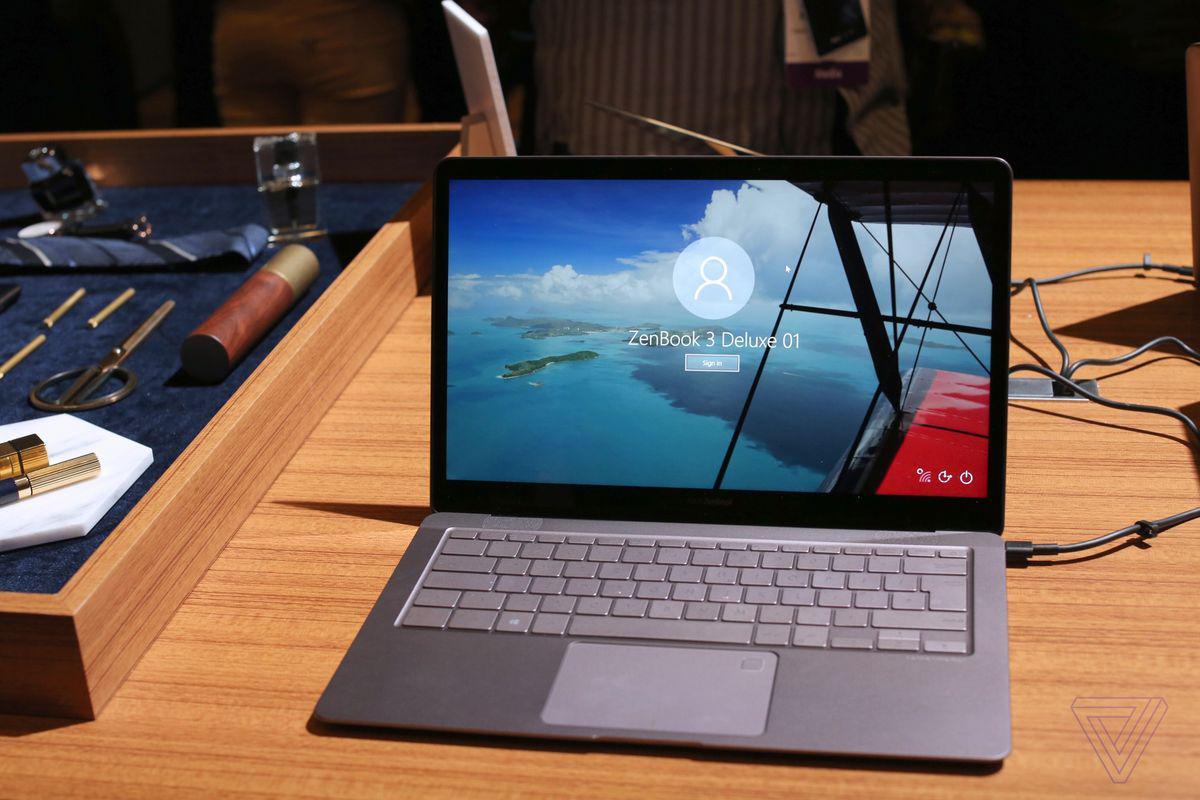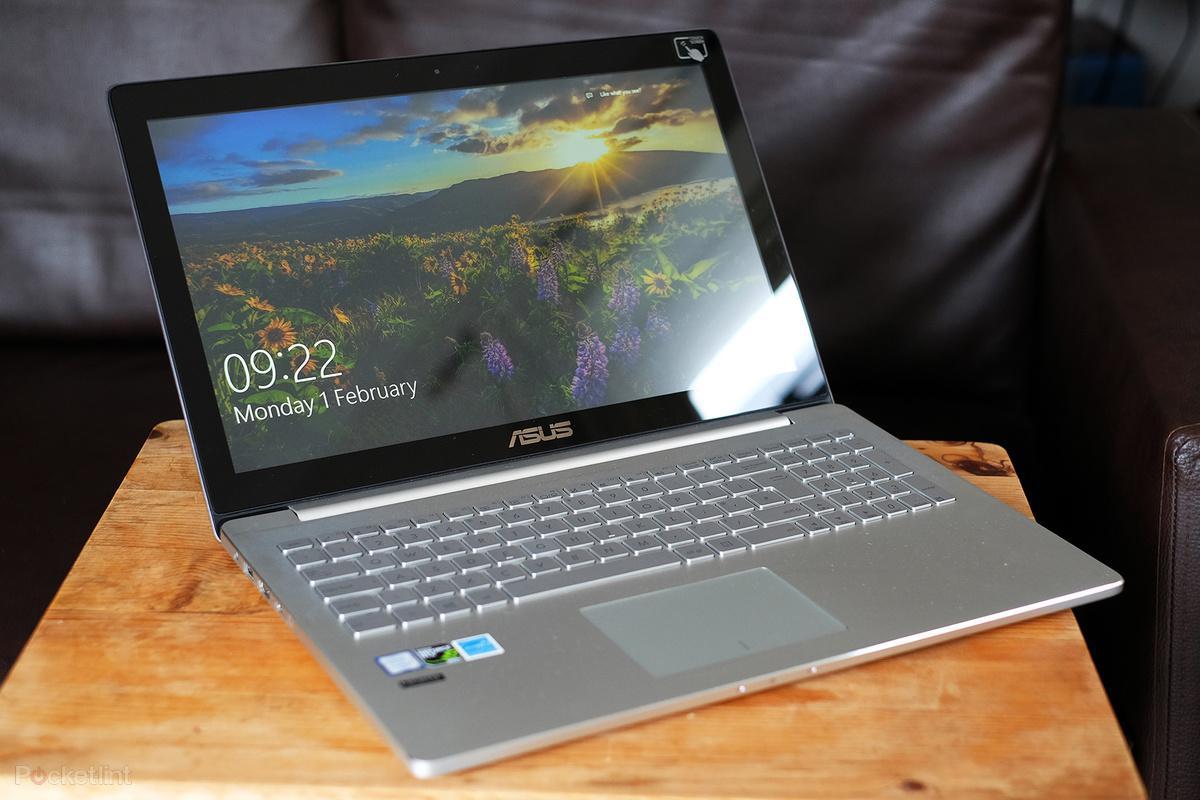The first image is the image on the left, the second image is the image on the right. Given the left and right images, does the statement "There are multiple squares shown on a laptop screen in one of the images." hold true? Answer yes or no. No. The first image is the image on the left, the second image is the image on the right. For the images shown, is this caption "Each image shows one open laptop, and the lefthand laptop has a cord plugged into its right side." true? Answer yes or no. Yes. 